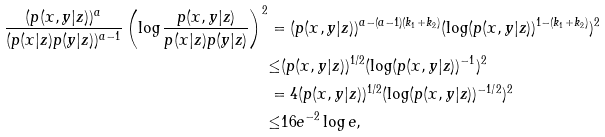Convert formula to latex. <formula><loc_0><loc_0><loc_500><loc_500>\frac { ( p ( x , y | z ) ) ^ { a } } { ( p ( x | z ) p ( y | z ) ) ^ { a - 1 } } \left ( \log \frac { p ( x , y | z ) } { p ( x | z ) p ( y | z ) } \right ) ^ { 2 } & = ( p ( x , y | z ) ) ^ { a - ( a - 1 ) ( k _ { 1 } + k _ { 2 } ) } ( \log ( p ( x , y | z ) ) ^ { 1 - ( k _ { 1 } + k _ { 2 } ) } ) ^ { 2 } \\ & { \leq } ( p ( x , y | z ) ) ^ { 1 / 2 } ( \log ( p ( x , y | z ) ) ^ { - 1 } ) ^ { 2 } \\ & = 4 ( p ( x , y | z ) ) ^ { 1 / 2 } ( \log ( p ( x , y | z ) ) ^ { - 1 / 2 } ) ^ { 2 } \\ & { \leq } 1 6 e ^ { - 2 } \log e ,</formula> 